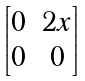<formula> <loc_0><loc_0><loc_500><loc_500>\begin{bmatrix} 0 & 2 x \\ 0 & 0 \end{bmatrix}</formula> 